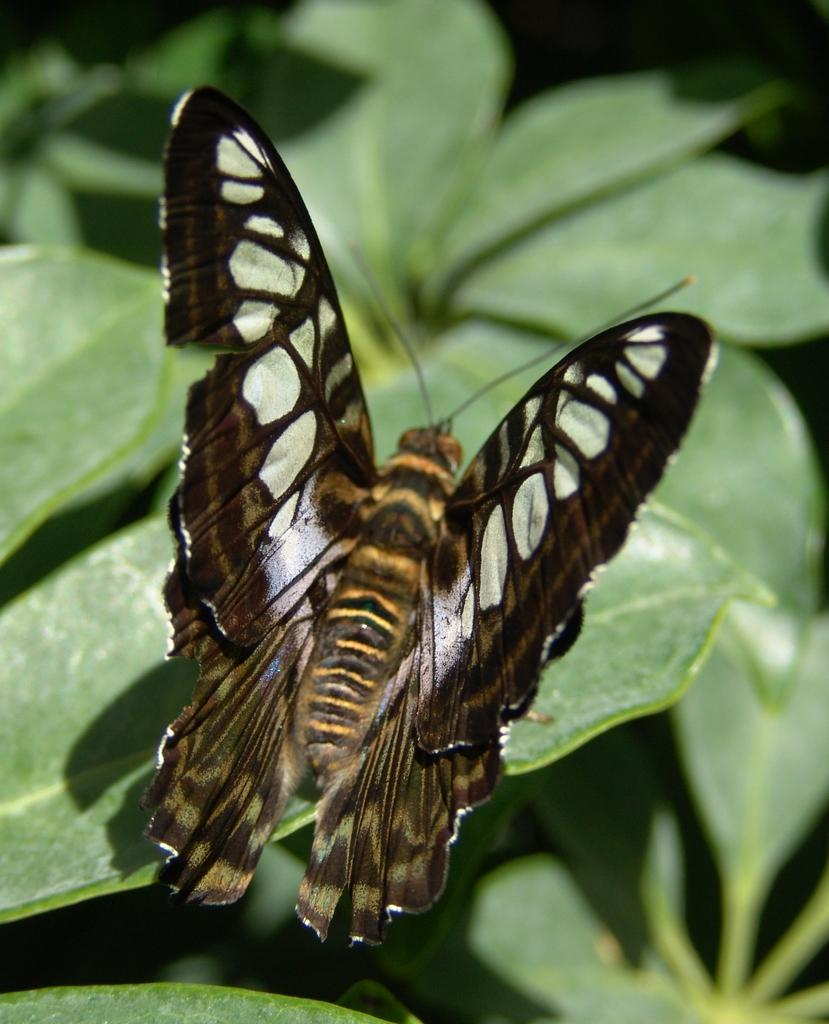What type of vegetation can be seen in the image? There are leaves in the image. What animal is present in the image? There is a butterfly in the middle of the image. What type of insurance is being advertised in the image? There is no insurance being advertised in the image; it features leaves and a butterfly. What message of peace can be seen in the image? There is no message of peace present in the image; it only features leaves and a butterfly. 